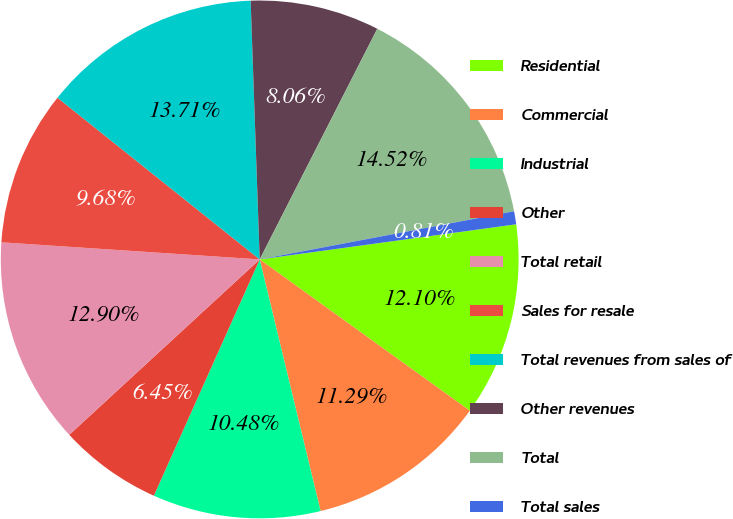Convert chart to OTSL. <chart><loc_0><loc_0><loc_500><loc_500><pie_chart><fcel>Residential<fcel>Commercial<fcel>Industrial<fcel>Other<fcel>Total retail<fcel>Sales for resale<fcel>Total revenues from sales of<fcel>Other revenues<fcel>Total<fcel>Total sales<nl><fcel>12.1%<fcel>11.29%<fcel>10.48%<fcel>6.45%<fcel>12.9%<fcel>9.68%<fcel>13.71%<fcel>8.06%<fcel>14.52%<fcel>0.81%<nl></chart> 